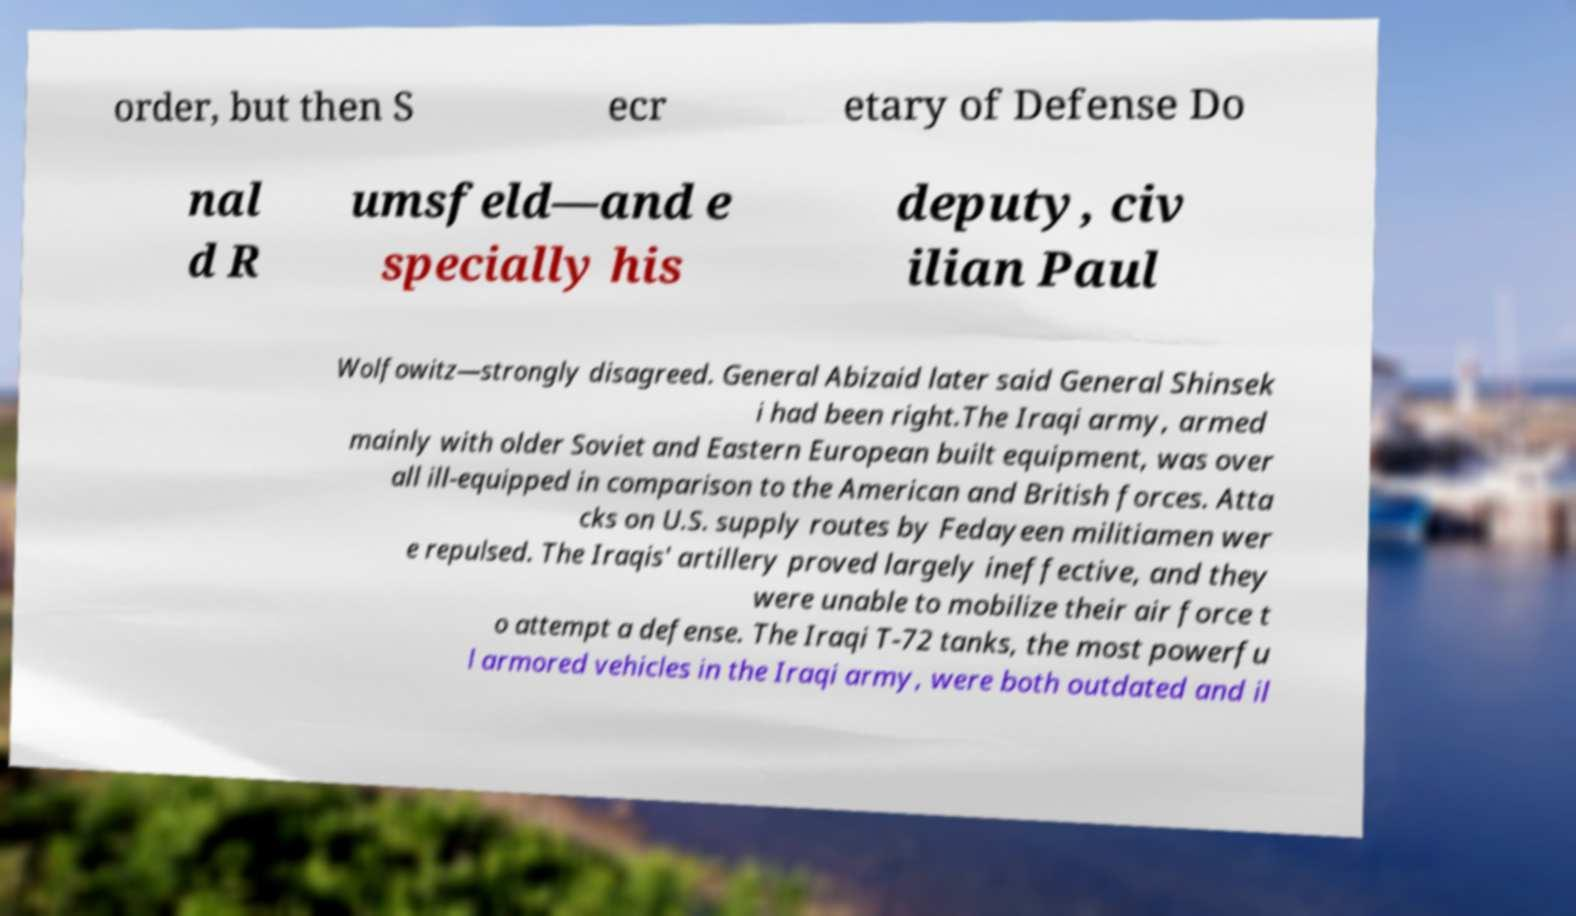For documentation purposes, I need the text within this image transcribed. Could you provide that? order, but then S ecr etary of Defense Do nal d R umsfeld—and e specially his deputy, civ ilian Paul Wolfowitz—strongly disagreed. General Abizaid later said General Shinsek i had been right.The Iraqi army, armed mainly with older Soviet and Eastern European built equipment, was over all ill-equipped in comparison to the American and British forces. Atta cks on U.S. supply routes by Fedayeen militiamen wer e repulsed. The Iraqis' artillery proved largely ineffective, and they were unable to mobilize their air force t o attempt a defense. The Iraqi T-72 tanks, the most powerfu l armored vehicles in the Iraqi army, were both outdated and il 